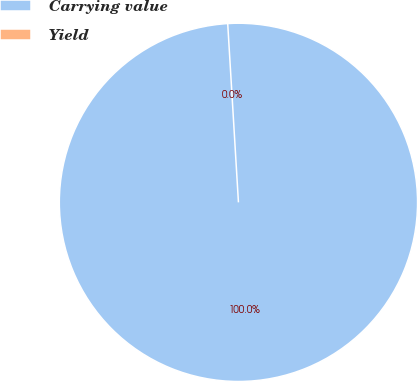Convert chart. <chart><loc_0><loc_0><loc_500><loc_500><pie_chart><fcel>Carrying value<fcel>Yield<nl><fcel>100.0%<fcel>0.0%<nl></chart> 